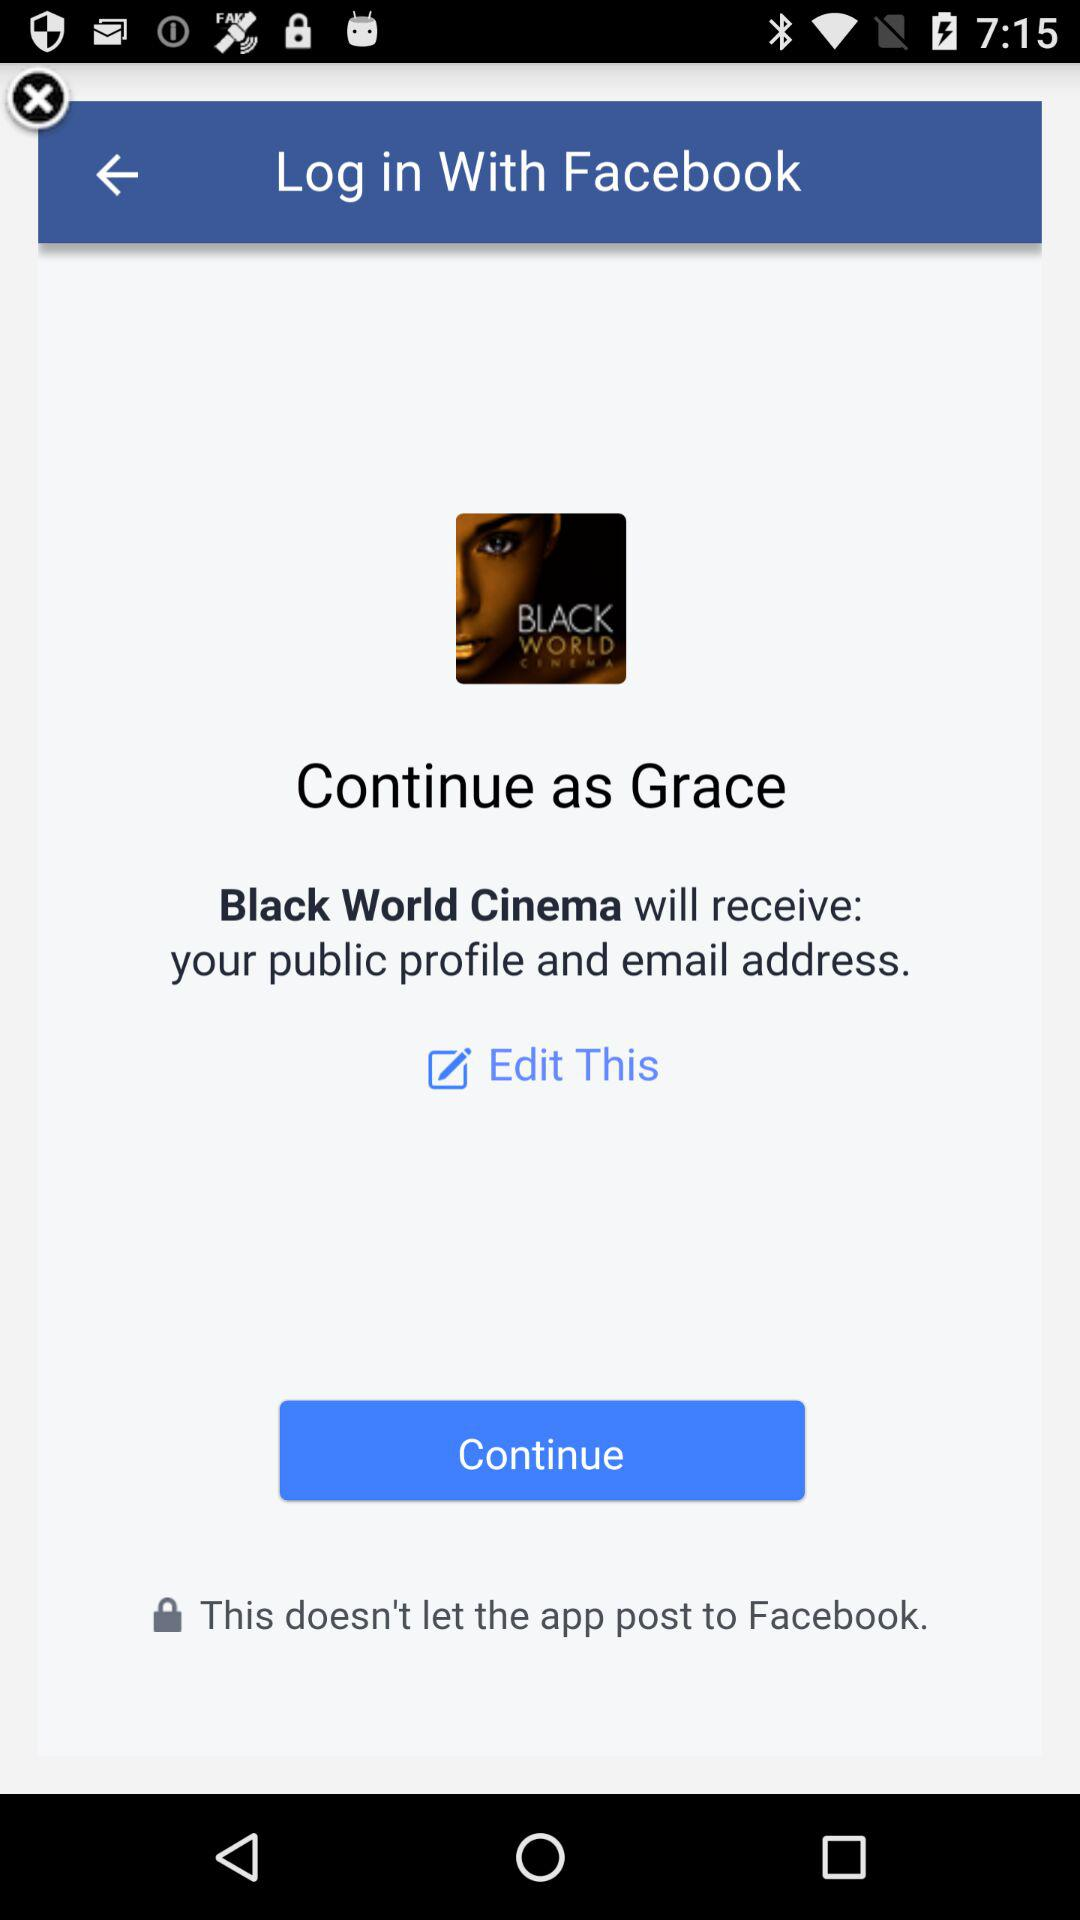What is the user name? The user name is Grace. 